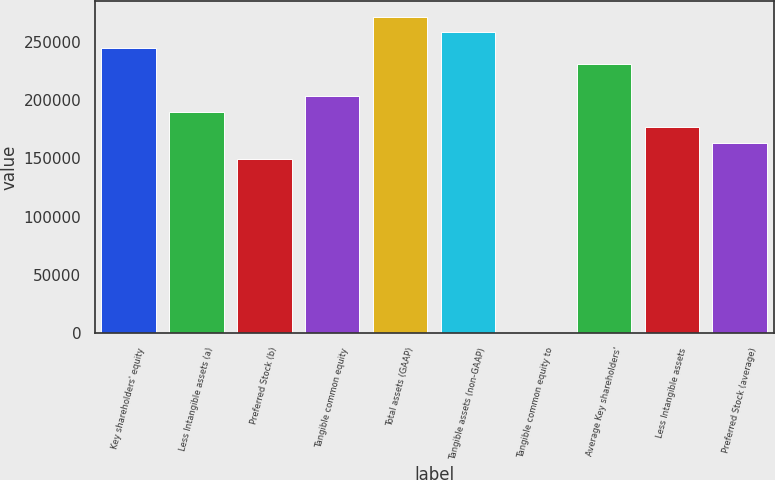Convert chart to OTSL. <chart><loc_0><loc_0><loc_500><loc_500><bar_chart><fcel>Key shareholders' equity<fcel>Less Intangible assets (a)<fcel>Preferred Stock (b)<fcel>Tangible common equity<fcel>Total assets (GAAP)<fcel>Tangible assets (non-GAAP)<fcel>Tangible common equity to<fcel>Average Key shareholders'<fcel>Less Intangible assets<fcel>Preferred Stock (average)<nl><fcel>244476<fcel>190150<fcel>149406<fcel>203732<fcel>271639<fcel>258058<fcel>8.56<fcel>230895<fcel>176569<fcel>162987<nl></chart> 